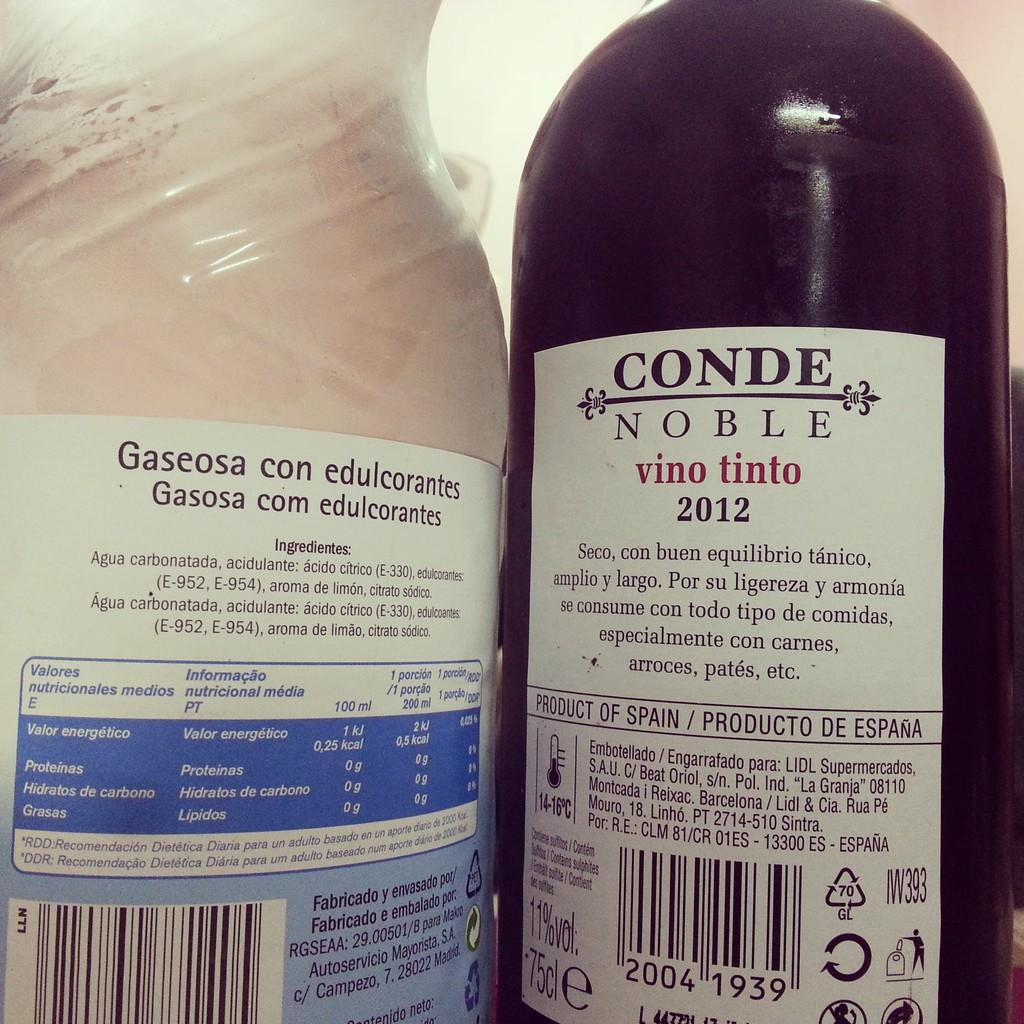What year was conde noble made?
Provide a succinct answer. 2012. What is the year of the bottle?
Your answer should be compact. 2012. 